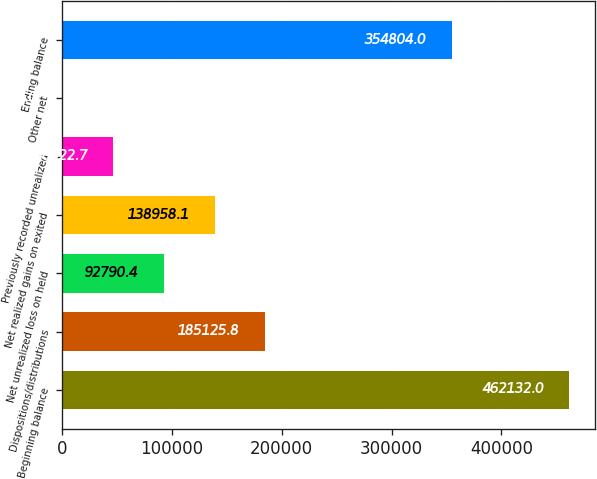Convert chart. <chart><loc_0><loc_0><loc_500><loc_500><bar_chart><fcel>Beginning balance<fcel>Dispositions/distributions<fcel>Net unrealized loss on held<fcel>Net realized gains on exited<fcel>Previously recorded unrealized<fcel>Other net<fcel>Ending balance<nl><fcel>462132<fcel>185126<fcel>92790.4<fcel>138958<fcel>46622.7<fcel>455<fcel>354804<nl></chart> 